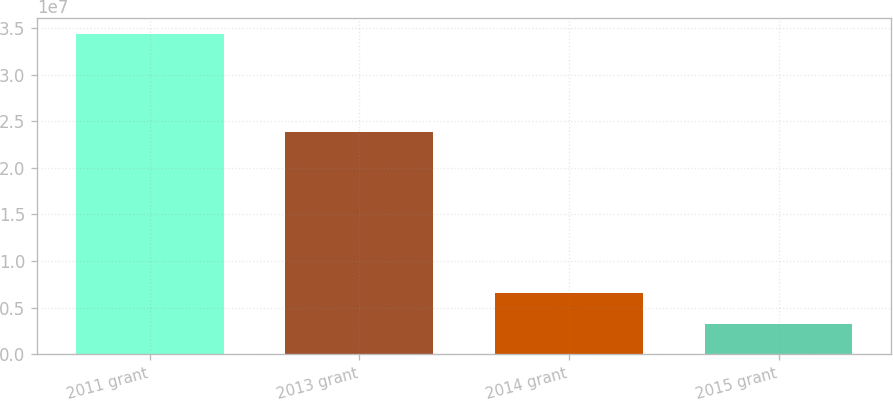<chart> <loc_0><loc_0><loc_500><loc_500><bar_chart><fcel>2011 grant<fcel>2013 grant<fcel>2014 grant<fcel>2015 grant<nl><fcel>3.4331e+07<fcel>2.3804e+07<fcel>6.559e+06<fcel>3.205e+06<nl></chart> 